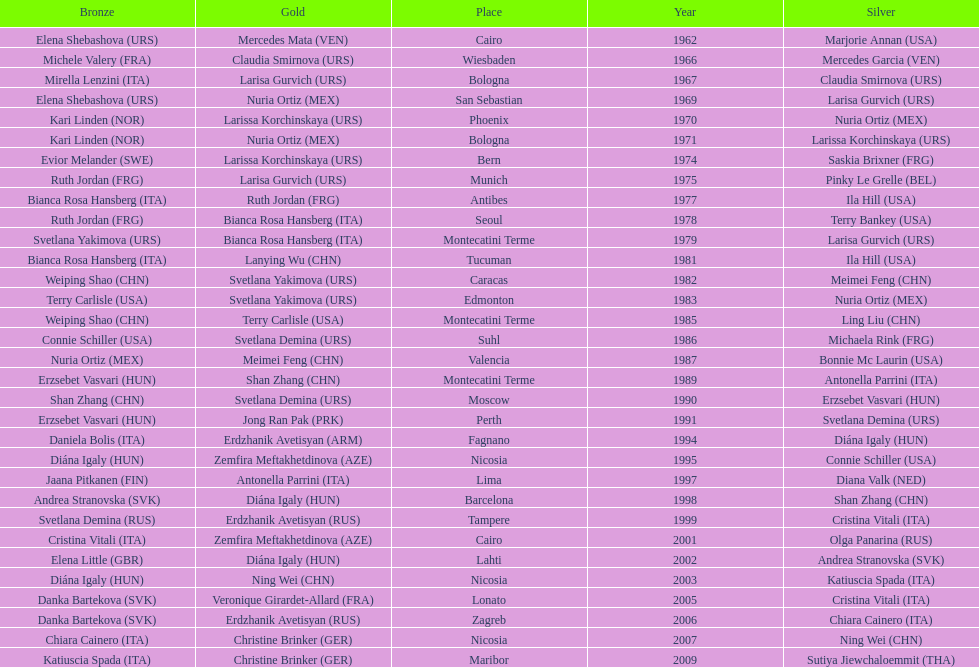Give me the full table as a dictionary. {'header': ['Bronze', 'Gold', 'Place', 'Year', 'Silver'], 'rows': [['Elena Shebashova\xa0(URS)', 'Mercedes Mata\xa0(VEN)', 'Cairo', '1962', 'Marjorie Annan\xa0(USA)'], ['Michele Valery\xa0(FRA)', 'Claudia Smirnova\xa0(URS)', 'Wiesbaden', '1966', 'Mercedes Garcia\xa0(VEN)'], ['Mirella Lenzini\xa0(ITA)', 'Larisa Gurvich\xa0(URS)', 'Bologna', '1967', 'Claudia Smirnova\xa0(URS)'], ['Elena Shebashova\xa0(URS)', 'Nuria Ortiz\xa0(MEX)', 'San Sebastian', '1969', 'Larisa Gurvich\xa0(URS)'], ['Kari Linden\xa0(NOR)', 'Larissa Korchinskaya\xa0(URS)', 'Phoenix', '1970', 'Nuria Ortiz\xa0(MEX)'], ['Kari Linden\xa0(NOR)', 'Nuria Ortiz\xa0(MEX)', 'Bologna', '1971', 'Larissa Korchinskaya\xa0(URS)'], ['Evior Melander\xa0(SWE)', 'Larissa Korchinskaya\xa0(URS)', 'Bern', '1974', 'Saskia Brixner\xa0(FRG)'], ['Ruth Jordan\xa0(FRG)', 'Larisa Gurvich\xa0(URS)', 'Munich', '1975', 'Pinky Le Grelle\xa0(BEL)'], ['Bianca Rosa Hansberg\xa0(ITA)', 'Ruth Jordan\xa0(FRG)', 'Antibes', '1977', 'Ila Hill\xa0(USA)'], ['Ruth Jordan\xa0(FRG)', 'Bianca Rosa Hansberg\xa0(ITA)', 'Seoul', '1978', 'Terry Bankey\xa0(USA)'], ['Svetlana Yakimova\xa0(URS)', 'Bianca Rosa Hansberg\xa0(ITA)', 'Montecatini Terme', '1979', 'Larisa Gurvich\xa0(URS)'], ['Bianca Rosa Hansberg\xa0(ITA)', 'Lanying Wu\xa0(CHN)', 'Tucuman', '1981', 'Ila Hill\xa0(USA)'], ['Weiping Shao\xa0(CHN)', 'Svetlana Yakimova\xa0(URS)', 'Caracas', '1982', 'Meimei Feng\xa0(CHN)'], ['Terry Carlisle\xa0(USA)', 'Svetlana Yakimova\xa0(URS)', 'Edmonton', '1983', 'Nuria Ortiz\xa0(MEX)'], ['Weiping Shao\xa0(CHN)', 'Terry Carlisle\xa0(USA)', 'Montecatini Terme', '1985', 'Ling Liu\xa0(CHN)'], ['Connie Schiller\xa0(USA)', 'Svetlana Demina\xa0(URS)', 'Suhl', '1986', 'Michaela Rink\xa0(FRG)'], ['Nuria Ortiz\xa0(MEX)', 'Meimei Feng\xa0(CHN)', 'Valencia', '1987', 'Bonnie Mc Laurin\xa0(USA)'], ['Erzsebet Vasvari\xa0(HUN)', 'Shan Zhang\xa0(CHN)', 'Montecatini Terme', '1989', 'Antonella Parrini\xa0(ITA)'], ['Shan Zhang\xa0(CHN)', 'Svetlana Demina\xa0(URS)', 'Moscow', '1990', 'Erzsebet Vasvari\xa0(HUN)'], ['Erzsebet Vasvari\xa0(HUN)', 'Jong Ran Pak\xa0(PRK)', 'Perth', '1991', 'Svetlana Demina\xa0(URS)'], ['Daniela Bolis\xa0(ITA)', 'Erdzhanik Avetisyan\xa0(ARM)', 'Fagnano', '1994', 'Diána Igaly\xa0(HUN)'], ['Diána Igaly\xa0(HUN)', 'Zemfira Meftakhetdinova\xa0(AZE)', 'Nicosia', '1995', 'Connie Schiller\xa0(USA)'], ['Jaana Pitkanen\xa0(FIN)', 'Antonella Parrini\xa0(ITA)', 'Lima', '1997', 'Diana Valk\xa0(NED)'], ['Andrea Stranovska\xa0(SVK)', 'Diána Igaly\xa0(HUN)', 'Barcelona', '1998', 'Shan Zhang\xa0(CHN)'], ['Svetlana Demina\xa0(RUS)', 'Erdzhanik Avetisyan\xa0(RUS)', 'Tampere', '1999', 'Cristina Vitali\xa0(ITA)'], ['Cristina Vitali\xa0(ITA)', 'Zemfira Meftakhetdinova\xa0(AZE)', 'Cairo', '2001', 'Olga Panarina\xa0(RUS)'], ['Elena Little\xa0(GBR)', 'Diána Igaly\xa0(HUN)', 'Lahti', '2002', 'Andrea Stranovska\xa0(SVK)'], ['Diána Igaly\xa0(HUN)', 'Ning Wei\xa0(CHN)', 'Nicosia', '2003', 'Katiuscia Spada\xa0(ITA)'], ['Danka Bartekova\xa0(SVK)', 'Veronique Girardet-Allard\xa0(FRA)', 'Lonato', '2005', 'Cristina Vitali\xa0(ITA)'], ['Danka Bartekova\xa0(SVK)', 'Erdzhanik Avetisyan\xa0(RUS)', 'Zagreb', '2006', 'Chiara Cainero\xa0(ITA)'], ['Chiara Cainero\xa0(ITA)', 'Christine Brinker\xa0(GER)', 'Nicosia', '2007', 'Ning Wei\xa0(CHN)'], ['Katiuscia Spada\xa0(ITA)', 'Christine Brinker\xa0(GER)', 'Maribor', '2009', 'Sutiya Jiewchaloemmit\xa0(THA)']]} Which country has won more gold medals: china or mexico? China. 